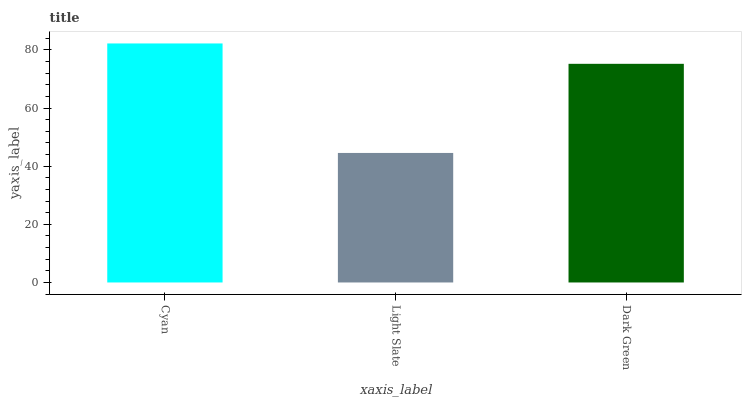Is Light Slate the minimum?
Answer yes or no. Yes. Is Cyan the maximum?
Answer yes or no. Yes. Is Dark Green the minimum?
Answer yes or no. No. Is Dark Green the maximum?
Answer yes or no. No. Is Dark Green greater than Light Slate?
Answer yes or no. Yes. Is Light Slate less than Dark Green?
Answer yes or no. Yes. Is Light Slate greater than Dark Green?
Answer yes or no. No. Is Dark Green less than Light Slate?
Answer yes or no. No. Is Dark Green the high median?
Answer yes or no. Yes. Is Dark Green the low median?
Answer yes or no. Yes. Is Cyan the high median?
Answer yes or no. No. Is Cyan the low median?
Answer yes or no. No. 